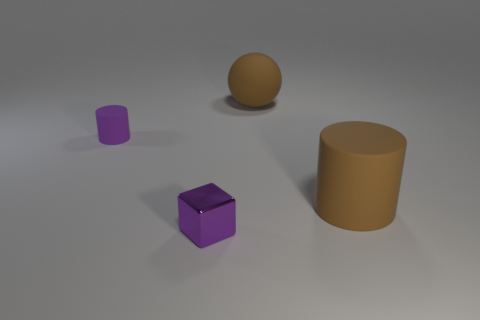Add 2 big purple cylinders. How many objects exist? 6 Subtract all large gray metal cubes. Subtract all big brown balls. How many objects are left? 3 Add 4 tiny purple things. How many tiny purple things are left? 6 Add 3 purple objects. How many purple objects exist? 5 Subtract 0 cyan cubes. How many objects are left? 4 Subtract all blocks. How many objects are left? 3 Subtract all blue cylinders. Subtract all green spheres. How many cylinders are left? 2 Subtract all green spheres. How many purple cylinders are left? 1 